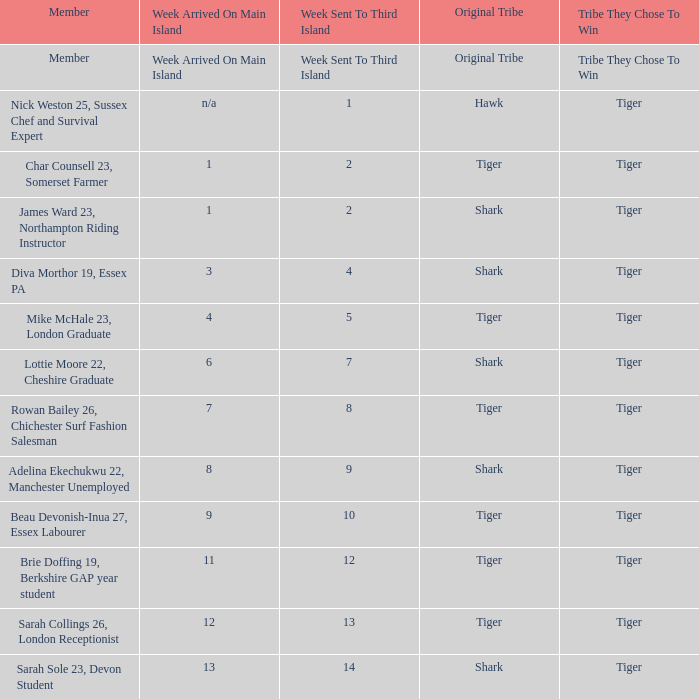Who was assigned to the third island during the initial week? Nick Weston 25, Sussex Chef and Survival Expert. 